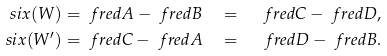<formula> <loc_0><loc_0><loc_500><loc_500>\ s i x ( W ) & = \ f r e d { A } - \ f r e d { B } \quad = \quad \ f r e d { C } - \ f r e d { D } , \\ \ s i x ( W ^ { \prime } ) & = \ f r e d { C } - \ f r e d { A } \quad = \quad \ f r e d { D } - \ f r e d { B } .</formula> 